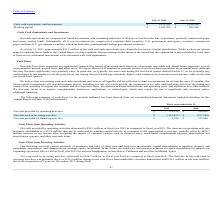According to Guidewire Software's financial document, What were the cash flows from operations impacted by? by timing of invoicing and collections of accounts receivable and annual bonus payments, as well as payments of payroll, payroll taxes, and other taxes.. The document states: "h flows from operations are significantly impacted by timing of invoicing and collections of accounts receivable and annual bonus payments, as well as..." Also, What was the Net cash provided by financing activities in 2019 and 2018 respectively? The document shows two values: $3,954 and $573,000 (in thousands). From the document: "t cash provided by financing activities $ 3,954 $ 573,000 Net cash provided by financing activities $ 3,954 $ 573,000..." Also, What was the Net cash provided by operating activities in 2019 and 2018 respectively? The document shows two values: $116,126 and $140,459 (in thousands). From the document: "cash provided by operating activities $ 116,126 $ 140,459 Net cash provided by operating activities $ 116,126 $ 140,459..." Also, can you calculate: What was the average Net cash provided by operating activities for 2018 and 2019? To answer this question, I need to perform calculations using the financial data. The calculation is: (116,126 + 140,459) / 2, which equals 128292.5 (in thousands). This is based on the information: "Net cash provided by operating activities $ 116,126 $ 140,459 cash provided by operating activities $ 116,126 $ 140,459..." The key data points involved are: 116,126, 140,459. Also, can you calculate: What is the change in the Net cash provided by financing activities from 2018 to 2019? Based on the calculation: 3,954 - 573,000, the result is -569046 (in thousands). This is based on the information: "Net cash provided by financing activities $ 3,954 $ 573,000 t cash provided by financing activities $ 3,954 $ 573,000..." The key data points involved are: 3,954, 573,000. Additionally, In which year was Net cash used in investing activities less than -350,000 thousands? According to the financial document, 2019. The relevant text states: "July 31, 2019 July 31, 2018..." 